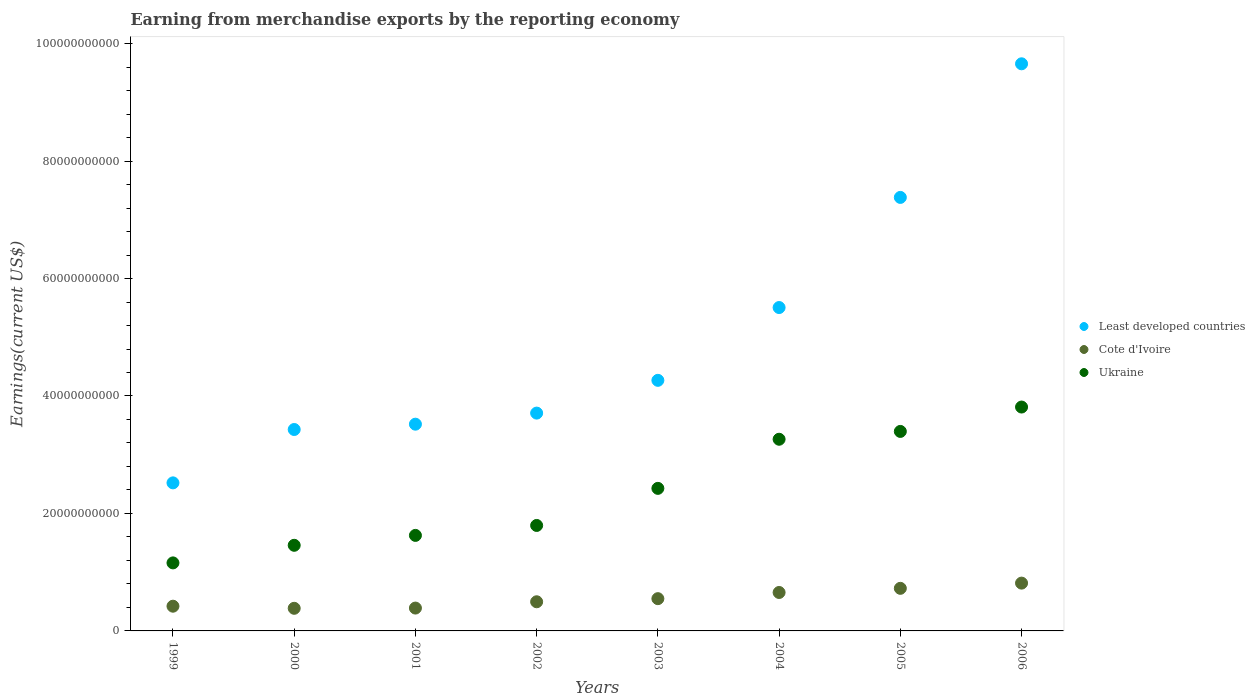How many different coloured dotlines are there?
Your response must be concise. 3. What is the amount earned from merchandise exports in Ukraine in 2002?
Provide a succinct answer. 1.80e+1. Across all years, what is the maximum amount earned from merchandise exports in Least developed countries?
Your response must be concise. 9.66e+1. Across all years, what is the minimum amount earned from merchandise exports in Cote d'Ivoire?
Your answer should be compact. 3.85e+09. In which year was the amount earned from merchandise exports in Cote d'Ivoire minimum?
Provide a succinct answer. 2000. What is the total amount earned from merchandise exports in Ukraine in the graph?
Offer a very short reply. 1.89e+11. What is the difference between the amount earned from merchandise exports in Least developed countries in 2001 and that in 2004?
Your answer should be compact. -1.99e+1. What is the difference between the amount earned from merchandise exports in Least developed countries in 2000 and the amount earned from merchandise exports in Cote d'Ivoire in 2005?
Provide a short and direct response. 2.70e+1. What is the average amount earned from merchandise exports in Cote d'Ivoire per year?
Your answer should be very brief. 5.54e+09. In the year 2006, what is the difference between the amount earned from merchandise exports in Least developed countries and amount earned from merchandise exports in Ukraine?
Your answer should be compact. 5.84e+1. What is the ratio of the amount earned from merchandise exports in Ukraine in 2002 to that in 2004?
Your answer should be very brief. 0.55. What is the difference between the highest and the second highest amount earned from merchandise exports in Least developed countries?
Your answer should be compact. 2.27e+1. What is the difference between the highest and the lowest amount earned from merchandise exports in Ukraine?
Ensure brevity in your answer.  2.65e+1. In how many years, is the amount earned from merchandise exports in Ukraine greater than the average amount earned from merchandise exports in Ukraine taken over all years?
Give a very brief answer. 4. Is the sum of the amount earned from merchandise exports in Ukraine in 1999 and 2001 greater than the maximum amount earned from merchandise exports in Cote d'Ivoire across all years?
Your response must be concise. Yes. Is it the case that in every year, the sum of the amount earned from merchandise exports in Least developed countries and amount earned from merchandise exports in Cote d'Ivoire  is greater than the amount earned from merchandise exports in Ukraine?
Make the answer very short. Yes. Is the amount earned from merchandise exports in Ukraine strictly greater than the amount earned from merchandise exports in Least developed countries over the years?
Your answer should be very brief. No. Is the amount earned from merchandise exports in Cote d'Ivoire strictly less than the amount earned from merchandise exports in Ukraine over the years?
Give a very brief answer. Yes. How many years are there in the graph?
Your answer should be compact. 8. What is the difference between two consecutive major ticks on the Y-axis?
Provide a succinct answer. 2.00e+1. Where does the legend appear in the graph?
Provide a succinct answer. Center right. What is the title of the graph?
Offer a terse response. Earning from merchandise exports by the reporting economy. What is the label or title of the Y-axis?
Offer a very short reply. Earnings(current US$). What is the Earnings(current US$) of Least developed countries in 1999?
Keep it short and to the point. 2.52e+1. What is the Earnings(current US$) in Cote d'Ivoire in 1999?
Offer a very short reply. 4.21e+09. What is the Earnings(current US$) in Ukraine in 1999?
Your answer should be very brief. 1.16e+1. What is the Earnings(current US$) in Least developed countries in 2000?
Provide a short and direct response. 3.43e+1. What is the Earnings(current US$) in Cote d'Ivoire in 2000?
Offer a terse response. 3.85e+09. What is the Earnings(current US$) in Ukraine in 2000?
Ensure brevity in your answer.  1.46e+1. What is the Earnings(current US$) of Least developed countries in 2001?
Make the answer very short. 3.52e+1. What is the Earnings(current US$) of Cote d'Ivoire in 2001?
Keep it short and to the point. 3.89e+09. What is the Earnings(current US$) of Ukraine in 2001?
Offer a very short reply. 1.63e+1. What is the Earnings(current US$) of Least developed countries in 2002?
Give a very brief answer. 3.71e+1. What is the Earnings(current US$) of Cote d'Ivoire in 2002?
Make the answer very short. 4.96e+09. What is the Earnings(current US$) in Ukraine in 2002?
Offer a very short reply. 1.80e+1. What is the Earnings(current US$) of Least developed countries in 2003?
Provide a short and direct response. 4.27e+1. What is the Earnings(current US$) in Cote d'Ivoire in 2003?
Your answer should be very brief. 5.49e+09. What is the Earnings(current US$) of Ukraine in 2003?
Make the answer very short. 2.43e+1. What is the Earnings(current US$) of Least developed countries in 2004?
Offer a very short reply. 5.51e+1. What is the Earnings(current US$) in Cote d'Ivoire in 2004?
Offer a very short reply. 6.55e+09. What is the Earnings(current US$) of Ukraine in 2004?
Provide a succinct answer. 3.26e+1. What is the Earnings(current US$) in Least developed countries in 2005?
Offer a terse response. 7.38e+1. What is the Earnings(current US$) of Cote d'Ivoire in 2005?
Offer a very short reply. 7.25e+09. What is the Earnings(current US$) in Ukraine in 2005?
Provide a short and direct response. 3.40e+1. What is the Earnings(current US$) in Least developed countries in 2006?
Your answer should be compact. 9.66e+1. What is the Earnings(current US$) in Cote d'Ivoire in 2006?
Provide a succinct answer. 8.14e+09. What is the Earnings(current US$) of Ukraine in 2006?
Provide a short and direct response. 3.81e+1. Across all years, what is the maximum Earnings(current US$) in Least developed countries?
Offer a terse response. 9.66e+1. Across all years, what is the maximum Earnings(current US$) in Cote d'Ivoire?
Give a very brief answer. 8.14e+09. Across all years, what is the maximum Earnings(current US$) of Ukraine?
Provide a short and direct response. 3.81e+1. Across all years, what is the minimum Earnings(current US$) in Least developed countries?
Ensure brevity in your answer.  2.52e+1. Across all years, what is the minimum Earnings(current US$) in Cote d'Ivoire?
Your response must be concise. 3.85e+09. Across all years, what is the minimum Earnings(current US$) of Ukraine?
Make the answer very short. 1.16e+1. What is the total Earnings(current US$) in Least developed countries in the graph?
Provide a short and direct response. 4.00e+11. What is the total Earnings(current US$) of Cote d'Ivoire in the graph?
Give a very brief answer. 4.43e+1. What is the total Earnings(current US$) of Ukraine in the graph?
Provide a short and direct response. 1.89e+11. What is the difference between the Earnings(current US$) in Least developed countries in 1999 and that in 2000?
Your answer should be very brief. -9.09e+09. What is the difference between the Earnings(current US$) in Cote d'Ivoire in 1999 and that in 2000?
Keep it short and to the point. 3.58e+08. What is the difference between the Earnings(current US$) of Ukraine in 1999 and that in 2000?
Offer a terse response. -3.00e+09. What is the difference between the Earnings(current US$) in Least developed countries in 1999 and that in 2001?
Keep it short and to the point. -9.99e+09. What is the difference between the Earnings(current US$) in Cote d'Ivoire in 1999 and that in 2001?
Offer a very short reply. 3.18e+08. What is the difference between the Earnings(current US$) in Ukraine in 1999 and that in 2001?
Give a very brief answer. -4.68e+09. What is the difference between the Earnings(current US$) of Least developed countries in 1999 and that in 2002?
Make the answer very short. -1.19e+1. What is the difference between the Earnings(current US$) in Cote d'Ivoire in 1999 and that in 2002?
Your response must be concise. -7.54e+08. What is the difference between the Earnings(current US$) of Ukraine in 1999 and that in 2002?
Your answer should be very brief. -6.37e+09. What is the difference between the Earnings(current US$) in Least developed countries in 1999 and that in 2003?
Your answer should be compact. -1.75e+1. What is the difference between the Earnings(current US$) of Cote d'Ivoire in 1999 and that in 2003?
Give a very brief answer. -1.28e+09. What is the difference between the Earnings(current US$) of Ukraine in 1999 and that in 2003?
Make the answer very short. -1.27e+1. What is the difference between the Earnings(current US$) in Least developed countries in 1999 and that in 2004?
Give a very brief answer. -2.99e+1. What is the difference between the Earnings(current US$) in Cote d'Ivoire in 1999 and that in 2004?
Your response must be concise. -2.34e+09. What is the difference between the Earnings(current US$) of Ukraine in 1999 and that in 2004?
Give a very brief answer. -2.11e+1. What is the difference between the Earnings(current US$) in Least developed countries in 1999 and that in 2005?
Your answer should be very brief. -4.86e+1. What is the difference between the Earnings(current US$) in Cote d'Ivoire in 1999 and that in 2005?
Keep it short and to the point. -3.04e+09. What is the difference between the Earnings(current US$) in Ukraine in 1999 and that in 2005?
Give a very brief answer. -2.24e+1. What is the difference between the Earnings(current US$) of Least developed countries in 1999 and that in 2006?
Offer a very short reply. -7.14e+1. What is the difference between the Earnings(current US$) in Cote d'Ivoire in 1999 and that in 2006?
Keep it short and to the point. -3.93e+09. What is the difference between the Earnings(current US$) in Ukraine in 1999 and that in 2006?
Keep it short and to the point. -2.65e+1. What is the difference between the Earnings(current US$) of Least developed countries in 2000 and that in 2001?
Keep it short and to the point. -9.05e+08. What is the difference between the Earnings(current US$) in Cote d'Ivoire in 2000 and that in 2001?
Provide a short and direct response. -3.96e+07. What is the difference between the Earnings(current US$) in Ukraine in 2000 and that in 2001?
Provide a succinct answer. -1.68e+09. What is the difference between the Earnings(current US$) of Least developed countries in 2000 and that in 2002?
Your response must be concise. -2.79e+09. What is the difference between the Earnings(current US$) in Cote d'Ivoire in 2000 and that in 2002?
Offer a terse response. -1.11e+09. What is the difference between the Earnings(current US$) of Ukraine in 2000 and that in 2002?
Your answer should be compact. -3.38e+09. What is the difference between the Earnings(current US$) of Least developed countries in 2000 and that in 2003?
Your response must be concise. -8.37e+09. What is the difference between the Earnings(current US$) of Cote d'Ivoire in 2000 and that in 2003?
Offer a terse response. -1.64e+09. What is the difference between the Earnings(current US$) in Ukraine in 2000 and that in 2003?
Provide a succinct answer. -9.69e+09. What is the difference between the Earnings(current US$) in Least developed countries in 2000 and that in 2004?
Make the answer very short. -2.08e+1. What is the difference between the Earnings(current US$) in Cote d'Ivoire in 2000 and that in 2004?
Your answer should be compact. -2.69e+09. What is the difference between the Earnings(current US$) of Ukraine in 2000 and that in 2004?
Offer a very short reply. -1.81e+1. What is the difference between the Earnings(current US$) of Least developed countries in 2000 and that in 2005?
Ensure brevity in your answer.  -3.95e+1. What is the difference between the Earnings(current US$) in Cote d'Ivoire in 2000 and that in 2005?
Offer a very short reply. -3.40e+09. What is the difference between the Earnings(current US$) of Ukraine in 2000 and that in 2005?
Provide a short and direct response. -1.94e+1. What is the difference between the Earnings(current US$) in Least developed countries in 2000 and that in 2006?
Give a very brief answer. -6.23e+1. What is the difference between the Earnings(current US$) in Cote d'Ivoire in 2000 and that in 2006?
Your response must be concise. -4.29e+09. What is the difference between the Earnings(current US$) of Ukraine in 2000 and that in 2006?
Offer a terse response. -2.35e+1. What is the difference between the Earnings(current US$) of Least developed countries in 2001 and that in 2002?
Give a very brief answer. -1.89e+09. What is the difference between the Earnings(current US$) of Cote d'Ivoire in 2001 and that in 2002?
Your response must be concise. -1.07e+09. What is the difference between the Earnings(current US$) in Ukraine in 2001 and that in 2002?
Provide a succinct answer. -1.69e+09. What is the difference between the Earnings(current US$) in Least developed countries in 2001 and that in 2003?
Your answer should be compact. -7.46e+09. What is the difference between the Earnings(current US$) in Cote d'Ivoire in 2001 and that in 2003?
Make the answer very short. -1.60e+09. What is the difference between the Earnings(current US$) of Ukraine in 2001 and that in 2003?
Make the answer very short. -8.01e+09. What is the difference between the Earnings(current US$) of Least developed countries in 2001 and that in 2004?
Keep it short and to the point. -1.99e+1. What is the difference between the Earnings(current US$) of Cote d'Ivoire in 2001 and that in 2004?
Your answer should be compact. -2.65e+09. What is the difference between the Earnings(current US$) of Ukraine in 2001 and that in 2004?
Your response must be concise. -1.64e+1. What is the difference between the Earnings(current US$) of Least developed countries in 2001 and that in 2005?
Offer a terse response. -3.86e+1. What is the difference between the Earnings(current US$) of Cote d'Ivoire in 2001 and that in 2005?
Offer a terse response. -3.36e+09. What is the difference between the Earnings(current US$) in Ukraine in 2001 and that in 2005?
Make the answer very short. -1.77e+1. What is the difference between the Earnings(current US$) of Least developed countries in 2001 and that in 2006?
Ensure brevity in your answer.  -6.14e+1. What is the difference between the Earnings(current US$) in Cote d'Ivoire in 2001 and that in 2006?
Your answer should be compact. -4.25e+09. What is the difference between the Earnings(current US$) in Ukraine in 2001 and that in 2006?
Your response must be concise. -2.19e+1. What is the difference between the Earnings(current US$) of Least developed countries in 2002 and that in 2003?
Give a very brief answer. -5.58e+09. What is the difference between the Earnings(current US$) in Cote d'Ivoire in 2002 and that in 2003?
Ensure brevity in your answer.  -5.30e+08. What is the difference between the Earnings(current US$) of Ukraine in 2002 and that in 2003?
Ensure brevity in your answer.  -6.31e+09. What is the difference between the Earnings(current US$) of Least developed countries in 2002 and that in 2004?
Offer a terse response. -1.80e+1. What is the difference between the Earnings(current US$) in Cote d'Ivoire in 2002 and that in 2004?
Ensure brevity in your answer.  -1.58e+09. What is the difference between the Earnings(current US$) of Ukraine in 2002 and that in 2004?
Make the answer very short. -1.47e+1. What is the difference between the Earnings(current US$) in Least developed countries in 2002 and that in 2005?
Make the answer very short. -3.67e+1. What is the difference between the Earnings(current US$) of Cote d'Ivoire in 2002 and that in 2005?
Your answer should be very brief. -2.29e+09. What is the difference between the Earnings(current US$) in Ukraine in 2002 and that in 2005?
Give a very brief answer. -1.60e+1. What is the difference between the Earnings(current US$) in Least developed countries in 2002 and that in 2006?
Provide a short and direct response. -5.95e+1. What is the difference between the Earnings(current US$) of Cote d'Ivoire in 2002 and that in 2006?
Your answer should be very brief. -3.17e+09. What is the difference between the Earnings(current US$) of Ukraine in 2002 and that in 2006?
Offer a terse response. -2.02e+1. What is the difference between the Earnings(current US$) in Least developed countries in 2003 and that in 2004?
Provide a succinct answer. -1.24e+1. What is the difference between the Earnings(current US$) of Cote d'Ivoire in 2003 and that in 2004?
Provide a short and direct response. -1.05e+09. What is the difference between the Earnings(current US$) of Ukraine in 2003 and that in 2004?
Offer a very short reply. -8.36e+09. What is the difference between the Earnings(current US$) in Least developed countries in 2003 and that in 2005?
Your answer should be very brief. -3.11e+1. What is the difference between the Earnings(current US$) of Cote d'Ivoire in 2003 and that in 2005?
Make the answer very short. -1.76e+09. What is the difference between the Earnings(current US$) in Ukraine in 2003 and that in 2005?
Provide a short and direct response. -9.70e+09. What is the difference between the Earnings(current US$) in Least developed countries in 2003 and that in 2006?
Provide a short and direct response. -5.39e+1. What is the difference between the Earnings(current US$) of Cote d'Ivoire in 2003 and that in 2006?
Offer a terse response. -2.65e+09. What is the difference between the Earnings(current US$) of Ukraine in 2003 and that in 2006?
Your answer should be very brief. -1.38e+1. What is the difference between the Earnings(current US$) of Least developed countries in 2004 and that in 2005?
Keep it short and to the point. -1.88e+1. What is the difference between the Earnings(current US$) of Cote d'Ivoire in 2004 and that in 2005?
Provide a succinct answer. -7.07e+08. What is the difference between the Earnings(current US$) in Ukraine in 2004 and that in 2005?
Provide a short and direct response. -1.33e+09. What is the difference between the Earnings(current US$) in Least developed countries in 2004 and that in 2006?
Give a very brief answer. -4.15e+1. What is the difference between the Earnings(current US$) of Cote d'Ivoire in 2004 and that in 2006?
Give a very brief answer. -1.59e+09. What is the difference between the Earnings(current US$) in Ukraine in 2004 and that in 2006?
Offer a terse response. -5.48e+09. What is the difference between the Earnings(current US$) in Least developed countries in 2005 and that in 2006?
Your answer should be very brief. -2.27e+1. What is the difference between the Earnings(current US$) in Cote d'Ivoire in 2005 and that in 2006?
Your answer should be very brief. -8.86e+08. What is the difference between the Earnings(current US$) of Ukraine in 2005 and that in 2006?
Offer a very short reply. -4.15e+09. What is the difference between the Earnings(current US$) in Least developed countries in 1999 and the Earnings(current US$) in Cote d'Ivoire in 2000?
Provide a succinct answer. 2.14e+1. What is the difference between the Earnings(current US$) of Least developed countries in 1999 and the Earnings(current US$) of Ukraine in 2000?
Offer a terse response. 1.06e+1. What is the difference between the Earnings(current US$) of Cote d'Ivoire in 1999 and the Earnings(current US$) of Ukraine in 2000?
Ensure brevity in your answer.  -1.04e+1. What is the difference between the Earnings(current US$) in Least developed countries in 1999 and the Earnings(current US$) in Cote d'Ivoire in 2001?
Make the answer very short. 2.13e+1. What is the difference between the Earnings(current US$) in Least developed countries in 1999 and the Earnings(current US$) in Ukraine in 2001?
Offer a very short reply. 8.95e+09. What is the difference between the Earnings(current US$) in Cote d'Ivoire in 1999 and the Earnings(current US$) in Ukraine in 2001?
Give a very brief answer. -1.21e+1. What is the difference between the Earnings(current US$) of Least developed countries in 1999 and the Earnings(current US$) of Cote d'Ivoire in 2002?
Your response must be concise. 2.02e+1. What is the difference between the Earnings(current US$) in Least developed countries in 1999 and the Earnings(current US$) in Ukraine in 2002?
Make the answer very short. 7.25e+09. What is the difference between the Earnings(current US$) of Cote d'Ivoire in 1999 and the Earnings(current US$) of Ukraine in 2002?
Provide a short and direct response. -1.37e+1. What is the difference between the Earnings(current US$) in Least developed countries in 1999 and the Earnings(current US$) in Cote d'Ivoire in 2003?
Your answer should be very brief. 1.97e+1. What is the difference between the Earnings(current US$) in Least developed countries in 1999 and the Earnings(current US$) in Ukraine in 2003?
Offer a very short reply. 9.37e+08. What is the difference between the Earnings(current US$) of Cote d'Ivoire in 1999 and the Earnings(current US$) of Ukraine in 2003?
Your response must be concise. -2.01e+1. What is the difference between the Earnings(current US$) in Least developed countries in 1999 and the Earnings(current US$) in Cote d'Ivoire in 2004?
Give a very brief answer. 1.87e+1. What is the difference between the Earnings(current US$) of Least developed countries in 1999 and the Earnings(current US$) of Ukraine in 2004?
Give a very brief answer. -7.43e+09. What is the difference between the Earnings(current US$) of Cote d'Ivoire in 1999 and the Earnings(current US$) of Ukraine in 2004?
Ensure brevity in your answer.  -2.84e+1. What is the difference between the Earnings(current US$) in Least developed countries in 1999 and the Earnings(current US$) in Cote d'Ivoire in 2005?
Your answer should be compact. 1.80e+1. What is the difference between the Earnings(current US$) of Least developed countries in 1999 and the Earnings(current US$) of Ukraine in 2005?
Keep it short and to the point. -8.76e+09. What is the difference between the Earnings(current US$) in Cote d'Ivoire in 1999 and the Earnings(current US$) in Ukraine in 2005?
Your answer should be compact. -2.98e+1. What is the difference between the Earnings(current US$) in Least developed countries in 1999 and the Earnings(current US$) in Cote d'Ivoire in 2006?
Your answer should be compact. 1.71e+1. What is the difference between the Earnings(current US$) in Least developed countries in 1999 and the Earnings(current US$) in Ukraine in 2006?
Provide a short and direct response. -1.29e+1. What is the difference between the Earnings(current US$) of Cote d'Ivoire in 1999 and the Earnings(current US$) of Ukraine in 2006?
Your response must be concise. -3.39e+1. What is the difference between the Earnings(current US$) of Least developed countries in 2000 and the Earnings(current US$) of Cote d'Ivoire in 2001?
Your answer should be compact. 3.04e+1. What is the difference between the Earnings(current US$) in Least developed countries in 2000 and the Earnings(current US$) in Ukraine in 2001?
Your answer should be compact. 1.80e+1. What is the difference between the Earnings(current US$) of Cote d'Ivoire in 2000 and the Earnings(current US$) of Ukraine in 2001?
Ensure brevity in your answer.  -1.24e+1. What is the difference between the Earnings(current US$) of Least developed countries in 2000 and the Earnings(current US$) of Cote d'Ivoire in 2002?
Provide a short and direct response. 2.93e+1. What is the difference between the Earnings(current US$) in Least developed countries in 2000 and the Earnings(current US$) in Ukraine in 2002?
Provide a short and direct response. 1.63e+1. What is the difference between the Earnings(current US$) in Cote d'Ivoire in 2000 and the Earnings(current US$) in Ukraine in 2002?
Offer a terse response. -1.41e+1. What is the difference between the Earnings(current US$) in Least developed countries in 2000 and the Earnings(current US$) in Cote d'Ivoire in 2003?
Provide a succinct answer. 2.88e+1. What is the difference between the Earnings(current US$) in Least developed countries in 2000 and the Earnings(current US$) in Ukraine in 2003?
Offer a terse response. 1.00e+1. What is the difference between the Earnings(current US$) in Cote d'Ivoire in 2000 and the Earnings(current US$) in Ukraine in 2003?
Provide a succinct answer. -2.04e+1. What is the difference between the Earnings(current US$) of Least developed countries in 2000 and the Earnings(current US$) of Cote d'Ivoire in 2004?
Your answer should be very brief. 2.77e+1. What is the difference between the Earnings(current US$) in Least developed countries in 2000 and the Earnings(current US$) in Ukraine in 2004?
Keep it short and to the point. 1.66e+09. What is the difference between the Earnings(current US$) in Cote d'Ivoire in 2000 and the Earnings(current US$) in Ukraine in 2004?
Make the answer very short. -2.88e+1. What is the difference between the Earnings(current US$) in Least developed countries in 2000 and the Earnings(current US$) in Cote d'Ivoire in 2005?
Provide a succinct answer. 2.70e+1. What is the difference between the Earnings(current US$) in Least developed countries in 2000 and the Earnings(current US$) in Ukraine in 2005?
Provide a succinct answer. 3.27e+08. What is the difference between the Earnings(current US$) in Cote d'Ivoire in 2000 and the Earnings(current US$) in Ukraine in 2005?
Make the answer very short. -3.01e+1. What is the difference between the Earnings(current US$) in Least developed countries in 2000 and the Earnings(current US$) in Cote d'Ivoire in 2006?
Your answer should be compact. 2.62e+1. What is the difference between the Earnings(current US$) in Least developed countries in 2000 and the Earnings(current US$) in Ukraine in 2006?
Your response must be concise. -3.82e+09. What is the difference between the Earnings(current US$) of Cote d'Ivoire in 2000 and the Earnings(current US$) of Ukraine in 2006?
Offer a terse response. -3.43e+1. What is the difference between the Earnings(current US$) in Least developed countries in 2001 and the Earnings(current US$) in Cote d'Ivoire in 2002?
Your answer should be compact. 3.02e+1. What is the difference between the Earnings(current US$) of Least developed countries in 2001 and the Earnings(current US$) of Ukraine in 2002?
Your answer should be compact. 1.72e+1. What is the difference between the Earnings(current US$) in Cote d'Ivoire in 2001 and the Earnings(current US$) in Ukraine in 2002?
Provide a short and direct response. -1.41e+1. What is the difference between the Earnings(current US$) of Least developed countries in 2001 and the Earnings(current US$) of Cote d'Ivoire in 2003?
Offer a terse response. 2.97e+1. What is the difference between the Earnings(current US$) in Least developed countries in 2001 and the Earnings(current US$) in Ukraine in 2003?
Offer a very short reply. 1.09e+1. What is the difference between the Earnings(current US$) in Cote d'Ivoire in 2001 and the Earnings(current US$) in Ukraine in 2003?
Give a very brief answer. -2.04e+1. What is the difference between the Earnings(current US$) in Least developed countries in 2001 and the Earnings(current US$) in Cote d'Ivoire in 2004?
Make the answer very short. 2.87e+1. What is the difference between the Earnings(current US$) of Least developed countries in 2001 and the Earnings(current US$) of Ukraine in 2004?
Your answer should be very brief. 2.57e+09. What is the difference between the Earnings(current US$) of Cote d'Ivoire in 2001 and the Earnings(current US$) of Ukraine in 2004?
Give a very brief answer. -2.87e+1. What is the difference between the Earnings(current US$) of Least developed countries in 2001 and the Earnings(current US$) of Cote d'Ivoire in 2005?
Your response must be concise. 2.79e+1. What is the difference between the Earnings(current US$) of Least developed countries in 2001 and the Earnings(current US$) of Ukraine in 2005?
Your answer should be very brief. 1.23e+09. What is the difference between the Earnings(current US$) in Cote d'Ivoire in 2001 and the Earnings(current US$) in Ukraine in 2005?
Your answer should be very brief. -3.01e+1. What is the difference between the Earnings(current US$) in Least developed countries in 2001 and the Earnings(current US$) in Cote d'Ivoire in 2006?
Make the answer very short. 2.71e+1. What is the difference between the Earnings(current US$) in Least developed countries in 2001 and the Earnings(current US$) in Ukraine in 2006?
Offer a very short reply. -2.92e+09. What is the difference between the Earnings(current US$) in Cote d'Ivoire in 2001 and the Earnings(current US$) in Ukraine in 2006?
Provide a short and direct response. -3.42e+1. What is the difference between the Earnings(current US$) in Least developed countries in 2002 and the Earnings(current US$) in Cote d'Ivoire in 2003?
Give a very brief answer. 3.16e+1. What is the difference between the Earnings(current US$) of Least developed countries in 2002 and the Earnings(current US$) of Ukraine in 2003?
Offer a very short reply. 1.28e+1. What is the difference between the Earnings(current US$) of Cote d'Ivoire in 2002 and the Earnings(current US$) of Ukraine in 2003?
Provide a short and direct response. -1.93e+1. What is the difference between the Earnings(current US$) in Least developed countries in 2002 and the Earnings(current US$) in Cote d'Ivoire in 2004?
Offer a very short reply. 3.05e+1. What is the difference between the Earnings(current US$) of Least developed countries in 2002 and the Earnings(current US$) of Ukraine in 2004?
Provide a succinct answer. 4.45e+09. What is the difference between the Earnings(current US$) in Cote d'Ivoire in 2002 and the Earnings(current US$) in Ukraine in 2004?
Keep it short and to the point. -2.77e+1. What is the difference between the Earnings(current US$) of Least developed countries in 2002 and the Earnings(current US$) of Cote d'Ivoire in 2005?
Your answer should be compact. 2.98e+1. What is the difference between the Earnings(current US$) in Least developed countries in 2002 and the Earnings(current US$) in Ukraine in 2005?
Your response must be concise. 3.12e+09. What is the difference between the Earnings(current US$) in Cote d'Ivoire in 2002 and the Earnings(current US$) in Ukraine in 2005?
Your answer should be very brief. -2.90e+1. What is the difference between the Earnings(current US$) of Least developed countries in 2002 and the Earnings(current US$) of Cote d'Ivoire in 2006?
Your response must be concise. 2.89e+1. What is the difference between the Earnings(current US$) of Least developed countries in 2002 and the Earnings(current US$) of Ukraine in 2006?
Ensure brevity in your answer.  -1.03e+09. What is the difference between the Earnings(current US$) in Cote d'Ivoire in 2002 and the Earnings(current US$) in Ukraine in 2006?
Ensure brevity in your answer.  -3.32e+1. What is the difference between the Earnings(current US$) in Least developed countries in 2003 and the Earnings(current US$) in Cote d'Ivoire in 2004?
Provide a short and direct response. 3.61e+1. What is the difference between the Earnings(current US$) of Least developed countries in 2003 and the Earnings(current US$) of Ukraine in 2004?
Make the answer very short. 1.00e+1. What is the difference between the Earnings(current US$) of Cote d'Ivoire in 2003 and the Earnings(current US$) of Ukraine in 2004?
Your answer should be very brief. -2.71e+1. What is the difference between the Earnings(current US$) in Least developed countries in 2003 and the Earnings(current US$) in Cote d'Ivoire in 2005?
Your answer should be compact. 3.54e+1. What is the difference between the Earnings(current US$) of Least developed countries in 2003 and the Earnings(current US$) of Ukraine in 2005?
Your answer should be very brief. 8.70e+09. What is the difference between the Earnings(current US$) of Cote d'Ivoire in 2003 and the Earnings(current US$) of Ukraine in 2005?
Ensure brevity in your answer.  -2.85e+1. What is the difference between the Earnings(current US$) of Least developed countries in 2003 and the Earnings(current US$) of Cote d'Ivoire in 2006?
Give a very brief answer. 3.45e+1. What is the difference between the Earnings(current US$) of Least developed countries in 2003 and the Earnings(current US$) of Ukraine in 2006?
Your response must be concise. 4.55e+09. What is the difference between the Earnings(current US$) in Cote d'Ivoire in 2003 and the Earnings(current US$) in Ukraine in 2006?
Offer a very short reply. -3.26e+1. What is the difference between the Earnings(current US$) of Least developed countries in 2004 and the Earnings(current US$) of Cote d'Ivoire in 2005?
Keep it short and to the point. 4.78e+1. What is the difference between the Earnings(current US$) in Least developed countries in 2004 and the Earnings(current US$) in Ukraine in 2005?
Provide a succinct answer. 2.11e+1. What is the difference between the Earnings(current US$) in Cote d'Ivoire in 2004 and the Earnings(current US$) in Ukraine in 2005?
Offer a very short reply. -2.74e+1. What is the difference between the Earnings(current US$) in Least developed countries in 2004 and the Earnings(current US$) in Cote d'Ivoire in 2006?
Keep it short and to the point. 4.69e+1. What is the difference between the Earnings(current US$) of Least developed countries in 2004 and the Earnings(current US$) of Ukraine in 2006?
Your answer should be very brief. 1.69e+1. What is the difference between the Earnings(current US$) of Cote d'Ivoire in 2004 and the Earnings(current US$) of Ukraine in 2006?
Give a very brief answer. -3.16e+1. What is the difference between the Earnings(current US$) of Least developed countries in 2005 and the Earnings(current US$) of Cote d'Ivoire in 2006?
Offer a terse response. 6.57e+1. What is the difference between the Earnings(current US$) in Least developed countries in 2005 and the Earnings(current US$) in Ukraine in 2006?
Offer a very short reply. 3.57e+1. What is the difference between the Earnings(current US$) of Cote d'Ivoire in 2005 and the Earnings(current US$) of Ukraine in 2006?
Make the answer very short. -3.09e+1. What is the average Earnings(current US$) of Least developed countries per year?
Your answer should be very brief. 5.00e+1. What is the average Earnings(current US$) of Cote d'Ivoire per year?
Offer a very short reply. 5.54e+09. What is the average Earnings(current US$) of Ukraine per year?
Provide a short and direct response. 2.37e+1. In the year 1999, what is the difference between the Earnings(current US$) of Least developed countries and Earnings(current US$) of Cote d'Ivoire?
Your response must be concise. 2.10e+1. In the year 1999, what is the difference between the Earnings(current US$) of Least developed countries and Earnings(current US$) of Ukraine?
Your response must be concise. 1.36e+1. In the year 1999, what is the difference between the Earnings(current US$) of Cote d'Ivoire and Earnings(current US$) of Ukraine?
Your answer should be very brief. -7.37e+09. In the year 2000, what is the difference between the Earnings(current US$) of Least developed countries and Earnings(current US$) of Cote d'Ivoire?
Provide a succinct answer. 3.04e+1. In the year 2000, what is the difference between the Earnings(current US$) of Least developed countries and Earnings(current US$) of Ukraine?
Offer a very short reply. 1.97e+1. In the year 2000, what is the difference between the Earnings(current US$) in Cote d'Ivoire and Earnings(current US$) in Ukraine?
Your response must be concise. -1.07e+1. In the year 2001, what is the difference between the Earnings(current US$) in Least developed countries and Earnings(current US$) in Cote d'Ivoire?
Keep it short and to the point. 3.13e+1. In the year 2001, what is the difference between the Earnings(current US$) in Least developed countries and Earnings(current US$) in Ukraine?
Give a very brief answer. 1.89e+1. In the year 2001, what is the difference between the Earnings(current US$) in Cote d'Ivoire and Earnings(current US$) in Ukraine?
Give a very brief answer. -1.24e+1. In the year 2002, what is the difference between the Earnings(current US$) of Least developed countries and Earnings(current US$) of Cote d'Ivoire?
Offer a very short reply. 3.21e+1. In the year 2002, what is the difference between the Earnings(current US$) of Least developed countries and Earnings(current US$) of Ukraine?
Your answer should be very brief. 1.91e+1. In the year 2002, what is the difference between the Earnings(current US$) of Cote d'Ivoire and Earnings(current US$) of Ukraine?
Keep it short and to the point. -1.30e+1. In the year 2003, what is the difference between the Earnings(current US$) of Least developed countries and Earnings(current US$) of Cote d'Ivoire?
Offer a very short reply. 3.72e+1. In the year 2003, what is the difference between the Earnings(current US$) in Least developed countries and Earnings(current US$) in Ukraine?
Your answer should be very brief. 1.84e+1. In the year 2003, what is the difference between the Earnings(current US$) of Cote d'Ivoire and Earnings(current US$) of Ukraine?
Provide a succinct answer. -1.88e+1. In the year 2004, what is the difference between the Earnings(current US$) of Least developed countries and Earnings(current US$) of Cote d'Ivoire?
Keep it short and to the point. 4.85e+1. In the year 2004, what is the difference between the Earnings(current US$) of Least developed countries and Earnings(current US$) of Ukraine?
Ensure brevity in your answer.  2.24e+1. In the year 2004, what is the difference between the Earnings(current US$) in Cote d'Ivoire and Earnings(current US$) in Ukraine?
Make the answer very short. -2.61e+1. In the year 2005, what is the difference between the Earnings(current US$) in Least developed countries and Earnings(current US$) in Cote d'Ivoire?
Your response must be concise. 6.66e+1. In the year 2005, what is the difference between the Earnings(current US$) of Least developed countries and Earnings(current US$) of Ukraine?
Provide a succinct answer. 3.98e+1. In the year 2005, what is the difference between the Earnings(current US$) of Cote d'Ivoire and Earnings(current US$) of Ukraine?
Keep it short and to the point. -2.67e+1. In the year 2006, what is the difference between the Earnings(current US$) in Least developed countries and Earnings(current US$) in Cote d'Ivoire?
Offer a very short reply. 8.84e+1. In the year 2006, what is the difference between the Earnings(current US$) in Least developed countries and Earnings(current US$) in Ukraine?
Your answer should be very brief. 5.84e+1. In the year 2006, what is the difference between the Earnings(current US$) of Cote d'Ivoire and Earnings(current US$) of Ukraine?
Your answer should be compact. -3.00e+1. What is the ratio of the Earnings(current US$) in Least developed countries in 1999 to that in 2000?
Keep it short and to the point. 0.74. What is the ratio of the Earnings(current US$) in Cote d'Ivoire in 1999 to that in 2000?
Your answer should be compact. 1.09. What is the ratio of the Earnings(current US$) in Ukraine in 1999 to that in 2000?
Your answer should be compact. 0.79. What is the ratio of the Earnings(current US$) in Least developed countries in 1999 to that in 2001?
Make the answer very short. 0.72. What is the ratio of the Earnings(current US$) in Cote d'Ivoire in 1999 to that in 2001?
Give a very brief answer. 1.08. What is the ratio of the Earnings(current US$) of Ukraine in 1999 to that in 2001?
Make the answer very short. 0.71. What is the ratio of the Earnings(current US$) of Least developed countries in 1999 to that in 2002?
Offer a very short reply. 0.68. What is the ratio of the Earnings(current US$) in Cote d'Ivoire in 1999 to that in 2002?
Your response must be concise. 0.85. What is the ratio of the Earnings(current US$) in Ukraine in 1999 to that in 2002?
Offer a terse response. 0.65. What is the ratio of the Earnings(current US$) of Least developed countries in 1999 to that in 2003?
Provide a succinct answer. 0.59. What is the ratio of the Earnings(current US$) of Cote d'Ivoire in 1999 to that in 2003?
Provide a short and direct response. 0.77. What is the ratio of the Earnings(current US$) of Ukraine in 1999 to that in 2003?
Make the answer very short. 0.48. What is the ratio of the Earnings(current US$) of Least developed countries in 1999 to that in 2004?
Offer a terse response. 0.46. What is the ratio of the Earnings(current US$) of Cote d'Ivoire in 1999 to that in 2004?
Make the answer very short. 0.64. What is the ratio of the Earnings(current US$) of Ukraine in 1999 to that in 2004?
Offer a very short reply. 0.35. What is the ratio of the Earnings(current US$) of Least developed countries in 1999 to that in 2005?
Make the answer very short. 0.34. What is the ratio of the Earnings(current US$) in Cote d'Ivoire in 1999 to that in 2005?
Keep it short and to the point. 0.58. What is the ratio of the Earnings(current US$) of Ukraine in 1999 to that in 2005?
Provide a succinct answer. 0.34. What is the ratio of the Earnings(current US$) of Least developed countries in 1999 to that in 2006?
Ensure brevity in your answer.  0.26. What is the ratio of the Earnings(current US$) in Cote d'Ivoire in 1999 to that in 2006?
Offer a very short reply. 0.52. What is the ratio of the Earnings(current US$) of Ukraine in 1999 to that in 2006?
Your answer should be compact. 0.3. What is the ratio of the Earnings(current US$) of Least developed countries in 2000 to that in 2001?
Keep it short and to the point. 0.97. What is the ratio of the Earnings(current US$) in Ukraine in 2000 to that in 2001?
Ensure brevity in your answer.  0.9. What is the ratio of the Earnings(current US$) in Least developed countries in 2000 to that in 2002?
Ensure brevity in your answer.  0.92. What is the ratio of the Earnings(current US$) of Cote d'Ivoire in 2000 to that in 2002?
Offer a very short reply. 0.78. What is the ratio of the Earnings(current US$) in Ukraine in 2000 to that in 2002?
Keep it short and to the point. 0.81. What is the ratio of the Earnings(current US$) in Least developed countries in 2000 to that in 2003?
Keep it short and to the point. 0.8. What is the ratio of the Earnings(current US$) of Cote d'Ivoire in 2000 to that in 2003?
Your answer should be very brief. 0.7. What is the ratio of the Earnings(current US$) in Ukraine in 2000 to that in 2003?
Offer a very short reply. 0.6. What is the ratio of the Earnings(current US$) of Least developed countries in 2000 to that in 2004?
Offer a very short reply. 0.62. What is the ratio of the Earnings(current US$) in Cote d'Ivoire in 2000 to that in 2004?
Offer a very short reply. 0.59. What is the ratio of the Earnings(current US$) in Ukraine in 2000 to that in 2004?
Your answer should be very brief. 0.45. What is the ratio of the Earnings(current US$) in Least developed countries in 2000 to that in 2005?
Make the answer very short. 0.46. What is the ratio of the Earnings(current US$) of Cote d'Ivoire in 2000 to that in 2005?
Offer a terse response. 0.53. What is the ratio of the Earnings(current US$) in Ukraine in 2000 to that in 2005?
Keep it short and to the point. 0.43. What is the ratio of the Earnings(current US$) in Least developed countries in 2000 to that in 2006?
Provide a short and direct response. 0.36. What is the ratio of the Earnings(current US$) in Cote d'Ivoire in 2000 to that in 2006?
Your answer should be compact. 0.47. What is the ratio of the Earnings(current US$) of Ukraine in 2000 to that in 2006?
Provide a short and direct response. 0.38. What is the ratio of the Earnings(current US$) in Least developed countries in 2001 to that in 2002?
Provide a short and direct response. 0.95. What is the ratio of the Earnings(current US$) in Cote d'Ivoire in 2001 to that in 2002?
Keep it short and to the point. 0.78. What is the ratio of the Earnings(current US$) in Ukraine in 2001 to that in 2002?
Your answer should be compact. 0.91. What is the ratio of the Earnings(current US$) in Least developed countries in 2001 to that in 2003?
Offer a very short reply. 0.82. What is the ratio of the Earnings(current US$) of Cote d'Ivoire in 2001 to that in 2003?
Provide a succinct answer. 0.71. What is the ratio of the Earnings(current US$) of Ukraine in 2001 to that in 2003?
Make the answer very short. 0.67. What is the ratio of the Earnings(current US$) in Least developed countries in 2001 to that in 2004?
Give a very brief answer. 0.64. What is the ratio of the Earnings(current US$) in Cote d'Ivoire in 2001 to that in 2004?
Ensure brevity in your answer.  0.59. What is the ratio of the Earnings(current US$) of Ukraine in 2001 to that in 2004?
Give a very brief answer. 0.5. What is the ratio of the Earnings(current US$) in Least developed countries in 2001 to that in 2005?
Your answer should be compact. 0.48. What is the ratio of the Earnings(current US$) in Cote d'Ivoire in 2001 to that in 2005?
Your answer should be compact. 0.54. What is the ratio of the Earnings(current US$) of Ukraine in 2001 to that in 2005?
Provide a short and direct response. 0.48. What is the ratio of the Earnings(current US$) of Least developed countries in 2001 to that in 2006?
Your answer should be compact. 0.36. What is the ratio of the Earnings(current US$) of Cote d'Ivoire in 2001 to that in 2006?
Ensure brevity in your answer.  0.48. What is the ratio of the Earnings(current US$) of Ukraine in 2001 to that in 2006?
Your response must be concise. 0.43. What is the ratio of the Earnings(current US$) of Least developed countries in 2002 to that in 2003?
Ensure brevity in your answer.  0.87. What is the ratio of the Earnings(current US$) in Cote d'Ivoire in 2002 to that in 2003?
Your answer should be very brief. 0.9. What is the ratio of the Earnings(current US$) in Ukraine in 2002 to that in 2003?
Give a very brief answer. 0.74. What is the ratio of the Earnings(current US$) in Least developed countries in 2002 to that in 2004?
Your answer should be very brief. 0.67. What is the ratio of the Earnings(current US$) in Cote d'Ivoire in 2002 to that in 2004?
Ensure brevity in your answer.  0.76. What is the ratio of the Earnings(current US$) in Ukraine in 2002 to that in 2004?
Ensure brevity in your answer.  0.55. What is the ratio of the Earnings(current US$) of Least developed countries in 2002 to that in 2005?
Your answer should be compact. 0.5. What is the ratio of the Earnings(current US$) in Cote d'Ivoire in 2002 to that in 2005?
Your answer should be very brief. 0.68. What is the ratio of the Earnings(current US$) in Ukraine in 2002 to that in 2005?
Your answer should be compact. 0.53. What is the ratio of the Earnings(current US$) in Least developed countries in 2002 to that in 2006?
Provide a succinct answer. 0.38. What is the ratio of the Earnings(current US$) of Cote d'Ivoire in 2002 to that in 2006?
Provide a succinct answer. 0.61. What is the ratio of the Earnings(current US$) in Ukraine in 2002 to that in 2006?
Provide a short and direct response. 0.47. What is the ratio of the Earnings(current US$) of Least developed countries in 2003 to that in 2004?
Offer a terse response. 0.77. What is the ratio of the Earnings(current US$) of Cote d'Ivoire in 2003 to that in 2004?
Offer a terse response. 0.84. What is the ratio of the Earnings(current US$) in Ukraine in 2003 to that in 2004?
Ensure brevity in your answer.  0.74. What is the ratio of the Earnings(current US$) of Least developed countries in 2003 to that in 2005?
Provide a succinct answer. 0.58. What is the ratio of the Earnings(current US$) of Cote d'Ivoire in 2003 to that in 2005?
Your answer should be compact. 0.76. What is the ratio of the Earnings(current US$) in Ukraine in 2003 to that in 2005?
Offer a very short reply. 0.71. What is the ratio of the Earnings(current US$) in Least developed countries in 2003 to that in 2006?
Your answer should be very brief. 0.44. What is the ratio of the Earnings(current US$) of Cote d'Ivoire in 2003 to that in 2006?
Provide a short and direct response. 0.68. What is the ratio of the Earnings(current US$) in Ukraine in 2003 to that in 2006?
Offer a terse response. 0.64. What is the ratio of the Earnings(current US$) of Least developed countries in 2004 to that in 2005?
Provide a succinct answer. 0.75. What is the ratio of the Earnings(current US$) of Cote d'Ivoire in 2004 to that in 2005?
Provide a short and direct response. 0.9. What is the ratio of the Earnings(current US$) in Ukraine in 2004 to that in 2005?
Offer a terse response. 0.96. What is the ratio of the Earnings(current US$) of Least developed countries in 2004 to that in 2006?
Keep it short and to the point. 0.57. What is the ratio of the Earnings(current US$) in Cote d'Ivoire in 2004 to that in 2006?
Provide a succinct answer. 0.8. What is the ratio of the Earnings(current US$) of Ukraine in 2004 to that in 2006?
Offer a very short reply. 0.86. What is the ratio of the Earnings(current US$) in Least developed countries in 2005 to that in 2006?
Make the answer very short. 0.76. What is the ratio of the Earnings(current US$) in Cote d'Ivoire in 2005 to that in 2006?
Offer a terse response. 0.89. What is the ratio of the Earnings(current US$) of Ukraine in 2005 to that in 2006?
Offer a very short reply. 0.89. What is the difference between the highest and the second highest Earnings(current US$) in Least developed countries?
Your answer should be compact. 2.27e+1. What is the difference between the highest and the second highest Earnings(current US$) in Cote d'Ivoire?
Offer a terse response. 8.86e+08. What is the difference between the highest and the second highest Earnings(current US$) in Ukraine?
Make the answer very short. 4.15e+09. What is the difference between the highest and the lowest Earnings(current US$) in Least developed countries?
Provide a short and direct response. 7.14e+1. What is the difference between the highest and the lowest Earnings(current US$) in Cote d'Ivoire?
Your response must be concise. 4.29e+09. What is the difference between the highest and the lowest Earnings(current US$) of Ukraine?
Your answer should be compact. 2.65e+1. 